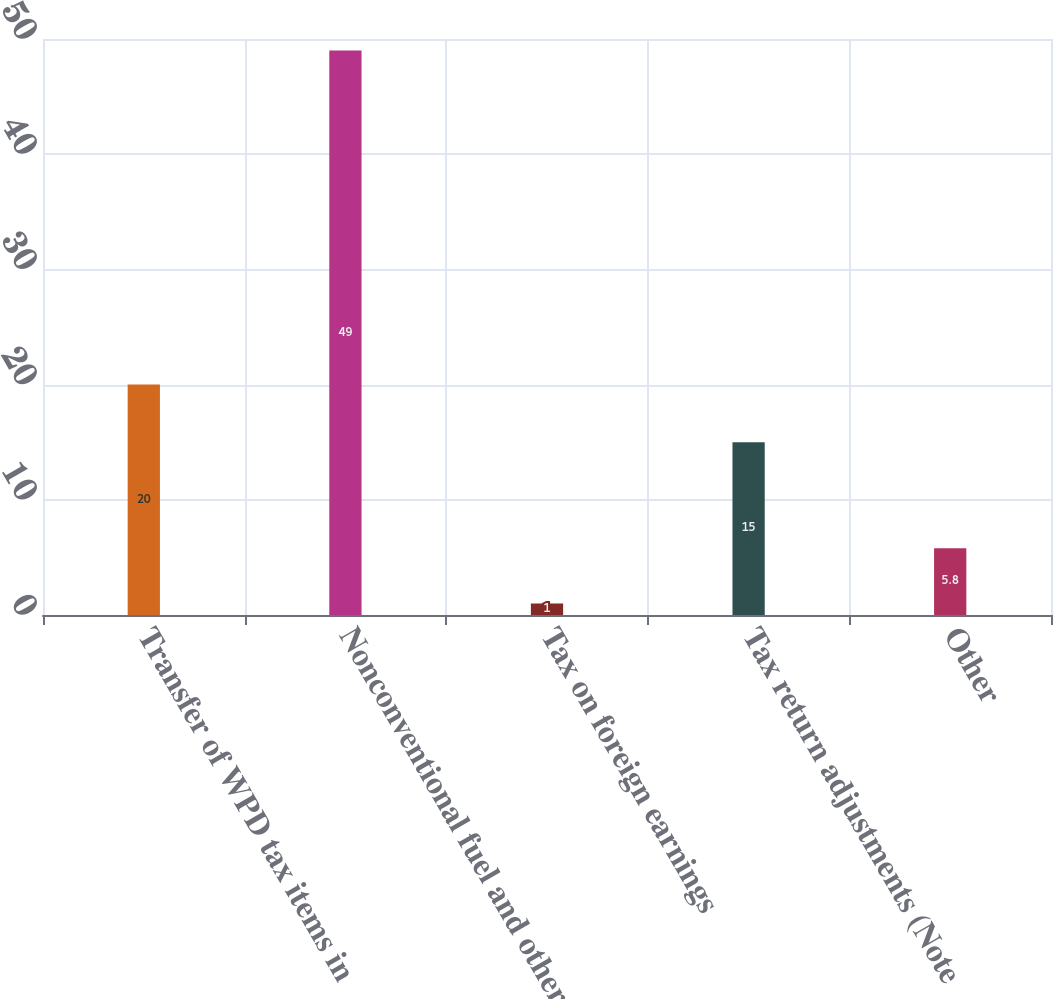Convert chart to OTSL. <chart><loc_0><loc_0><loc_500><loc_500><bar_chart><fcel>Transfer of WPD tax items in<fcel>Nonconventional fuel and other<fcel>Tax on foreign earnings<fcel>Tax return adjustments (Note<fcel>Other<nl><fcel>20<fcel>49<fcel>1<fcel>15<fcel>5.8<nl></chart> 